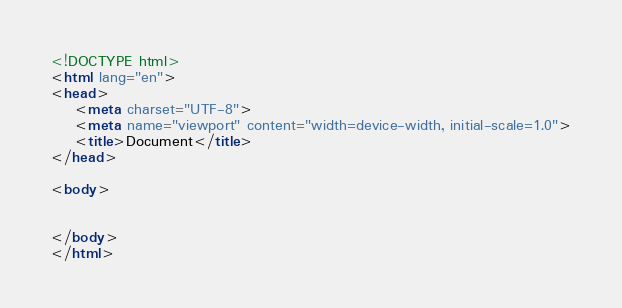Convert code to text. <code><loc_0><loc_0><loc_500><loc_500><_HTML_><!DOCTYPE html>
<html lang="en">
<head>
    <meta charset="UTF-8">
    <meta name="viewport" content="width=device-width, initial-scale=1.0">
    <title>Document</title>
</head>

<body>
    
    
</body>
</html></code> 